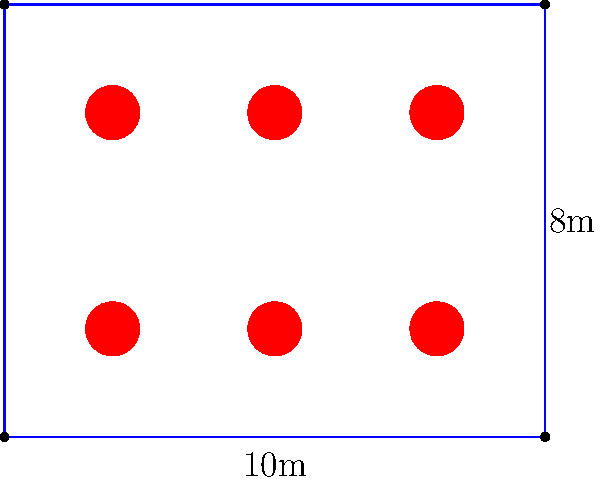As a restaurant PR agent, you're tasked with maximizing table arrangements for a high-profile event. The restaurant has a rectangular floor plan measuring 10m by 8m. Each circular table has a diameter of 1m and requires a minimum of 1m clearance on all sides for comfortable seating and service. What is the maximum number of tables that can be arranged in this space while maintaining the required clearance? To solve this optimization problem, we'll follow these steps:

1) First, we need to determine the effective space each table occupies, including its clearance:
   - Table diameter: 1m
   - Clearance on each side: 1m
   - Total space per table: $1m + 2(1m) = 3m$ in both length and width

2) Now, we can calculate how many tables can fit along each dimension:
   - Length: $10m \div 3m = 3.33$
   - Width: $8m \div 3m = 2.66$

3) Since we can't have fractional tables, we round down to the nearest whole number:
   - Length: 3 tables
   - Width: 2 tables

4) The total number of tables is the product of these two numbers:
   $3 \times 2 = 6$ tables

5) We can verify this arrangement:
   - 3 tables along the 10m length leaves $10m - (3 \times 3m) = 1m$ of excess space
   - 2 tables along the 8m width leaves $8m - (2 \times 3m) = 2m$ of excess space

This arrangement satisfies the clearance requirements while maximizing the number of tables.
Answer: 6 tables 